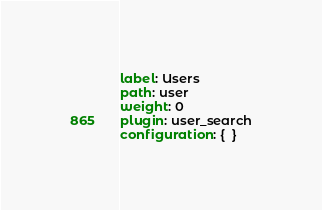Convert code to text. <code><loc_0><loc_0><loc_500><loc_500><_YAML_>label: Users
path: user
weight: 0
plugin: user_search
configuration: {  }
</code> 